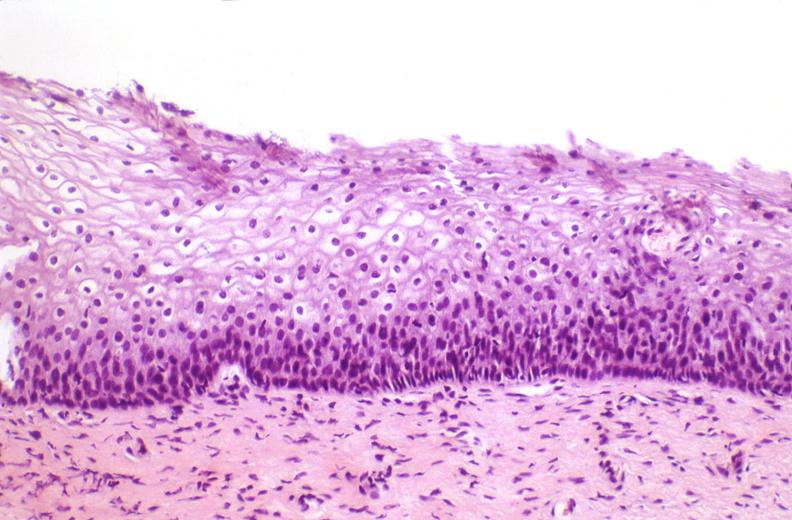does glioma show cervix, mild dysplasia?
Answer the question using a single word or phrase. No 